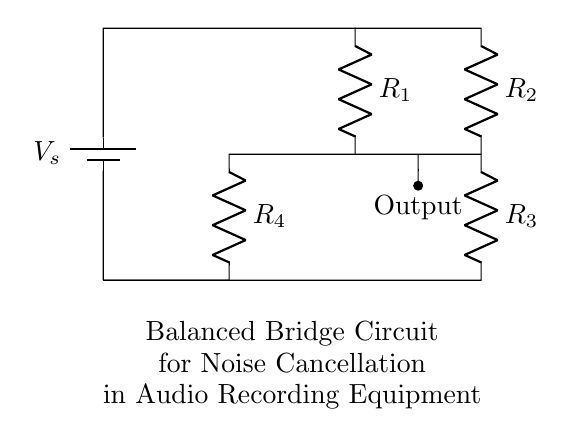What components are present in the circuit? The circuit contains a voltage source, four resistors, and an output lead. The resistors are labeled R1, R2, R3, and R4.
Answer: voltage source, four resistors What is the purpose of the bridge circuit? The purpose of the bridge circuit is to achieve noise cancellation in audio recording equipment, as indicated in the annotations of the diagram.
Answer: noise cancellation How many resistors are arranged in the circuit? There are four resistors arranged in the circuit, labeled R1, R2, R3, and R4.
Answer: four Which resistors are in series? R1 and R3 are arranged in series with the voltage source across them, while R2 and R4 are in series across the output.
Answer: R1 and R3 What is the expected output section of the circuit? The output section of the circuit is indicated by the node that connects to the output lead, which is also directed from R3 towards the output point.
Answer: output lead Explain the balance condition for this bridge. The balance condition for a bridge circuit is achieved when the ratio of the resistors in one leg (R1/R2) equals the ratio in the other leg (R3/R4). When this condition holds, the voltage across the output will be zero, indicating that the noise is canceled out.
Answer: R1/R2 = R3/R4 